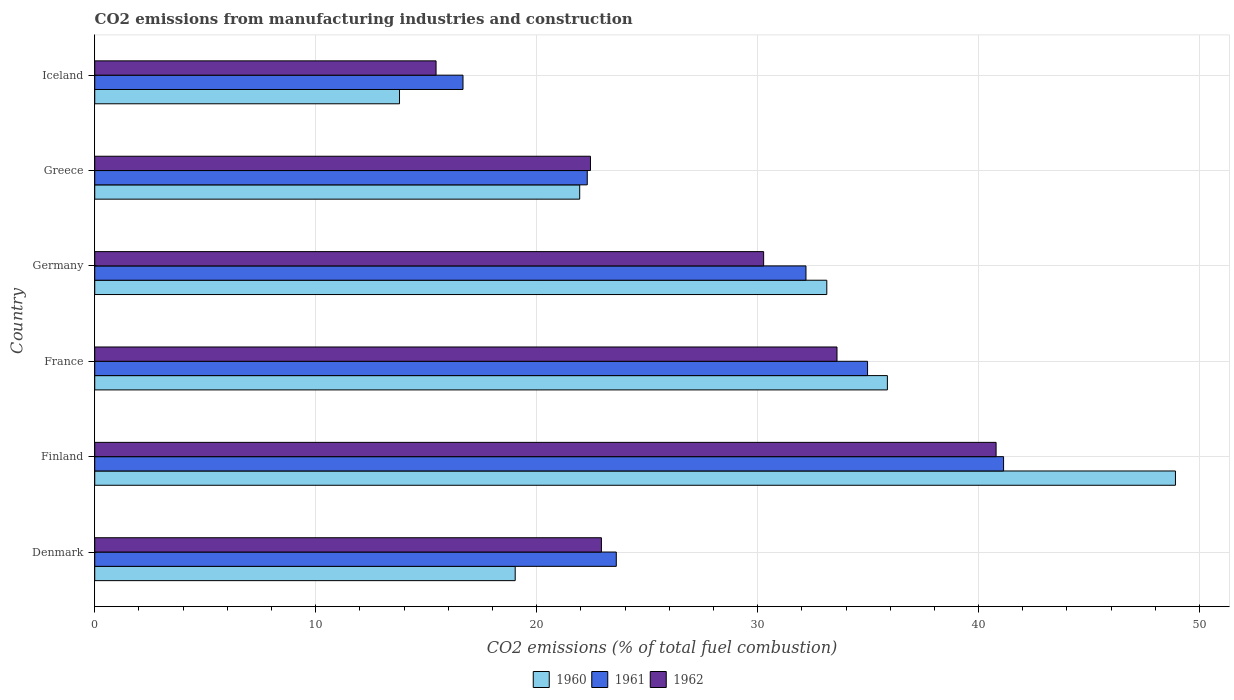How many bars are there on the 3rd tick from the bottom?
Give a very brief answer. 3. In how many cases, is the number of bars for a given country not equal to the number of legend labels?
Make the answer very short. 0. What is the amount of CO2 emitted in 1961 in Iceland?
Your answer should be very brief. 16.67. Across all countries, what is the maximum amount of CO2 emitted in 1962?
Provide a short and direct response. 40.79. Across all countries, what is the minimum amount of CO2 emitted in 1960?
Offer a very short reply. 13.79. In which country was the amount of CO2 emitted in 1960 maximum?
Provide a succinct answer. Finland. What is the total amount of CO2 emitted in 1961 in the graph?
Provide a succinct answer. 170.85. What is the difference between the amount of CO2 emitted in 1961 in Finland and that in Greece?
Offer a terse response. 18.84. What is the difference between the amount of CO2 emitted in 1962 in Iceland and the amount of CO2 emitted in 1960 in France?
Offer a terse response. -20.43. What is the average amount of CO2 emitted in 1960 per country?
Give a very brief answer. 28.78. What is the difference between the amount of CO2 emitted in 1961 and amount of CO2 emitted in 1960 in Denmark?
Offer a terse response. 4.57. In how many countries, is the amount of CO2 emitted in 1962 greater than 20 %?
Give a very brief answer. 5. What is the ratio of the amount of CO2 emitted in 1960 in France to that in Iceland?
Provide a succinct answer. 2.6. What is the difference between the highest and the second highest amount of CO2 emitted in 1960?
Your answer should be compact. 13.04. What is the difference between the highest and the lowest amount of CO2 emitted in 1962?
Provide a succinct answer. 25.34. What does the 1st bar from the top in Finland represents?
Keep it short and to the point. 1962. What does the 3rd bar from the bottom in Germany represents?
Your response must be concise. 1962. Is it the case that in every country, the sum of the amount of CO2 emitted in 1960 and amount of CO2 emitted in 1961 is greater than the amount of CO2 emitted in 1962?
Your answer should be compact. Yes. How many bars are there?
Your response must be concise. 18. Are all the bars in the graph horizontal?
Make the answer very short. Yes. Does the graph contain grids?
Your answer should be compact. Yes. How many legend labels are there?
Your answer should be very brief. 3. How are the legend labels stacked?
Make the answer very short. Horizontal. What is the title of the graph?
Offer a very short reply. CO2 emissions from manufacturing industries and construction. What is the label or title of the X-axis?
Provide a short and direct response. CO2 emissions (% of total fuel combustion). What is the CO2 emissions (% of total fuel combustion) of 1960 in Denmark?
Offer a very short reply. 19.03. What is the CO2 emissions (% of total fuel combustion) in 1961 in Denmark?
Provide a short and direct response. 23.6. What is the CO2 emissions (% of total fuel combustion) of 1962 in Denmark?
Your response must be concise. 22.93. What is the CO2 emissions (% of total fuel combustion) in 1960 in Finland?
Offer a very short reply. 48.91. What is the CO2 emissions (% of total fuel combustion) in 1961 in Finland?
Provide a succinct answer. 41.13. What is the CO2 emissions (% of total fuel combustion) in 1962 in Finland?
Your answer should be compact. 40.79. What is the CO2 emissions (% of total fuel combustion) in 1960 in France?
Give a very brief answer. 35.87. What is the CO2 emissions (% of total fuel combustion) of 1961 in France?
Your response must be concise. 34.98. What is the CO2 emissions (% of total fuel combustion) in 1962 in France?
Your answer should be very brief. 33.59. What is the CO2 emissions (% of total fuel combustion) in 1960 in Germany?
Your answer should be very brief. 33.13. What is the CO2 emissions (% of total fuel combustion) in 1961 in Germany?
Make the answer very short. 32.19. What is the CO2 emissions (% of total fuel combustion) in 1962 in Germany?
Offer a terse response. 30.27. What is the CO2 emissions (% of total fuel combustion) of 1960 in Greece?
Offer a terse response. 21.95. What is the CO2 emissions (% of total fuel combustion) in 1961 in Greece?
Your response must be concise. 22.29. What is the CO2 emissions (% of total fuel combustion) of 1962 in Greece?
Your response must be concise. 22.44. What is the CO2 emissions (% of total fuel combustion) in 1960 in Iceland?
Offer a very short reply. 13.79. What is the CO2 emissions (% of total fuel combustion) of 1961 in Iceland?
Offer a terse response. 16.67. What is the CO2 emissions (% of total fuel combustion) of 1962 in Iceland?
Offer a terse response. 15.45. Across all countries, what is the maximum CO2 emissions (% of total fuel combustion) of 1960?
Provide a succinct answer. 48.91. Across all countries, what is the maximum CO2 emissions (% of total fuel combustion) in 1961?
Provide a succinct answer. 41.13. Across all countries, what is the maximum CO2 emissions (% of total fuel combustion) in 1962?
Give a very brief answer. 40.79. Across all countries, what is the minimum CO2 emissions (% of total fuel combustion) in 1960?
Keep it short and to the point. 13.79. Across all countries, what is the minimum CO2 emissions (% of total fuel combustion) in 1961?
Make the answer very short. 16.67. Across all countries, what is the minimum CO2 emissions (% of total fuel combustion) in 1962?
Ensure brevity in your answer.  15.45. What is the total CO2 emissions (% of total fuel combustion) of 1960 in the graph?
Ensure brevity in your answer.  172.68. What is the total CO2 emissions (% of total fuel combustion) of 1961 in the graph?
Ensure brevity in your answer.  170.85. What is the total CO2 emissions (% of total fuel combustion) of 1962 in the graph?
Keep it short and to the point. 165.47. What is the difference between the CO2 emissions (% of total fuel combustion) of 1960 in Denmark and that in Finland?
Provide a succinct answer. -29.88. What is the difference between the CO2 emissions (% of total fuel combustion) in 1961 in Denmark and that in Finland?
Keep it short and to the point. -17.53. What is the difference between the CO2 emissions (% of total fuel combustion) of 1962 in Denmark and that in Finland?
Give a very brief answer. -17.86. What is the difference between the CO2 emissions (% of total fuel combustion) in 1960 in Denmark and that in France?
Provide a short and direct response. -16.84. What is the difference between the CO2 emissions (% of total fuel combustion) in 1961 in Denmark and that in France?
Ensure brevity in your answer.  -11.37. What is the difference between the CO2 emissions (% of total fuel combustion) in 1962 in Denmark and that in France?
Give a very brief answer. -10.66. What is the difference between the CO2 emissions (% of total fuel combustion) of 1960 in Denmark and that in Germany?
Ensure brevity in your answer.  -14.1. What is the difference between the CO2 emissions (% of total fuel combustion) of 1961 in Denmark and that in Germany?
Offer a very short reply. -8.58. What is the difference between the CO2 emissions (% of total fuel combustion) in 1962 in Denmark and that in Germany?
Make the answer very short. -7.34. What is the difference between the CO2 emissions (% of total fuel combustion) in 1960 in Denmark and that in Greece?
Keep it short and to the point. -2.92. What is the difference between the CO2 emissions (% of total fuel combustion) in 1961 in Denmark and that in Greece?
Your answer should be very brief. 1.31. What is the difference between the CO2 emissions (% of total fuel combustion) of 1962 in Denmark and that in Greece?
Give a very brief answer. 0.5. What is the difference between the CO2 emissions (% of total fuel combustion) of 1960 in Denmark and that in Iceland?
Offer a terse response. 5.24. What is the difference between the CO2 emissions (% of total fuel combustion) of 1961 in Denmark and that in Iceland?
Your answer should be compact. 6.94. What is the difference between the CO2 emissions (% of total fuel combustion) in 1962 in Denmark and that in Iceland?
Offer a terse response. 7.48. What is the difference between the CO2 emissions (% of total fuel combustion) in 1960 in Finland and that in France?
Your response must be concise. 13.04. What is the difference between the CO2 emissions (% of total fuel combustion) of 1961 in Finland and that in France?
Make the answer very short. 6.16. What is the difference between the CO2 emissions (% of total fuel combustion) of 1962 in Finland and that in France?
Your response must be concise. 7.2. What is the difference between the CO2 emissions (% of total fuel combustion) of 1960 in Finland and that in Germany?
Provide a succinct answer. 15.78. What is the difference between the CO2 emissions (% of total fuel combustion) in 1961 in Finland and that in Germany?
Offer a very short reply. 8.94. What is the difference between the CO2 emissions (% of total fuel combustion) in 1962 in Finland and that in Germany?
Provide a succinct answer. 10.52. What is the difference between the CO2 emissions (% of total fuel combustion) in 1960 in Finland and that in Greece?
Ensure brevity in your answer.  26.96. What is the difference between the CO2 emissions (% of total fuel combustion) of 1961 in Finland and that in Greece?
Your answer should be compact. 18.84. What is the difference between the CO2 emissions (% of total fuel combustion) of 1962 in Finland and that in Greece?
Offer a very short reply. 18.36. What is the difference between the CO2 emissions (% of total fuel combustion) in 1960 in Finland and that in Iceland?
Offer a very short reply. 35.12. What is the difference between the CO2 emissions (% of total fuel combustion) of 1961 in Finland and that in Iceland?
Provide a succinct answer. 24.46. What is the difference between the CO2 emissions (% of total fuel combustion) in 1962 in Finland and that in Iceland?
Your answer should be compact. 25.34. What is the difference between the CO2 emissions (% of total fuel combustion) of 1960 in France and that in Germany?
Your answer should be compact. 2.74. What is the difference between the CO2 emissions (% of total fuel combustion) in 1961 in France and that in Germany?
Your answer should be very brief. 2.79. What is the difference between the CO2 emissions (% of total fuel combustion) in 1962 in France and that in Germany?
Ensure brevity in your answer.  3.32. What is the difference between the CO2 emissions (% of total fuel combustion) of 1960 in France and that in Greece?
Your answer should be compact. 13.92. What is the difference between the CO2 emissions (% of total fuel combustion) in 1961 in France and that in Greece?
Your answer should be compact. 12.69. What is the difference between the CO2 emissions (% of total fuel combustion) of 1962 in France and that in Greece?
Provide a succinct answer. 11.16. What is the difference between the CO2 emissions (% of total fuel combustion) of 1960 in France and that in Iceland?
Your answer should be very brief. 22.08. What is the difference between the CO2 emissions (% of total fuel combustion) of 1961 in France and that in Iceland?
Your response must be concise. 18.31. What is the difference between the CO2 emissions (% of total fuel combustion) of 1962 in France and that in Iceland?
Provide a succinct answer. 18.14. What is the difference between the CO2 emissions (% of total fuel combustion) of 1960 in Germany and that in Greece?
Provide a succinct answer. 11.18. What is the difference between the CO2 emissions (% of total fuel combustion) in 1961 in Germany and that in Greece?
Give a very brief answer. 9.9. What is the difference between the CO2 emissions (% of total fuel combustion) in 1962 in Germany and that in Greece?
Offer a terse response. 7.84. What is the difference between the CO2 emissions (% of total fuel combustion) of 1960 in Germany and that in Iceland?
Keep it short and to the point. 19.34. What is the difference between the CO2 emissions (% of total fuel combustion) in 1961 in Germany and that in Iceland?
Keep it short and to the point. 15.52. What is the difference between the CO2 emissions (% of total fuel combustion) of 1962 in Germany and that in Iceland?
Offer a very short reply. 14.82. What is the difference between the CO2 emissions (% of total fuel combustion) in 1960 in Greece and that in Iceland?
Offer a terse response. 8.15. What is the difference between the CO2 emissions (% of total fuel combustion) of 1961 in Greece and that in Iceland?
Provide a short and direct response. 5.62. What is the difference between the CO2 emissions (% of total fuel combustion) of 1962 in Greece and that in Iceland?
Your response must be concise. 6.99. What is the difference between the CO2 emissions (% of total fuel combustion) of 1960 in Denmark and the CO2 emissions (% of total fuel combustion) of 1961 in Finland?
Make the answer very short. -22.1. What is the difference between the CO2 emissions (% of total fuel combustion) in 1960 in Denmark and the CO2 emissions (% of total fuel combustion) in 1962 in Finland?
Your answer should be compact. -21.76. What is the difference between the CO2 emissions (% of total fuel combustion) of 1961 in Denmark and the CO2 emissions (% of total fuel combustion) of 1962 in Finland?
Provide a short and direct response. -17.19. What is the difference between the CO2 emissions (% of total fuel combustion) in 1960 in Denmark and the CO2 emissions (% of total fuel combustion) in 1961 in France?
Provide a succinct answer. -15.95. What is the difference between the CO2 emissions (% of total fuel combustion) of 1960 in Denmark and the CO2 emissions (% of total fuel combustion) of 1962 in France?
Provide a short and direct response. -14.56. What is the difference between the CO2 emissions (% of total fuel combustion) in 1961 in Denmark and the CO2 emissions (% of total fuel combustion) in 1962 in France?
Keep it short and to the point. -9.99. What is the difference between the CO2 emissions (% of total fuel combustion) in 1960 in Denmark and the CO2 emissions (% of total fuel combustion) in 1961 in Germany?
Make the answer very short. -13.16. What is the difference between the CO2 emissions (% of total fuel combustion) of 1960 in Denmark and the CO2 emissions (% of total fuel combustion) of 1962 in Germany?
Offer a terse response. -11.24. What is the difference between the CO2 emissions (% of total fuel combustion) in 1961 in Denmark and the CO2 emissions (% of total fuel combustion) in 1962 in Germany?
Ensure brevity in your answer.  -6.67. What is the difference between the CO2 emissions (% of total fuel combustion) of 1960 in Denmark and the CO2 emissions (% of total fuel combustion) of 1961 in Greece?
Make the answer very short. -3.26. What is the difference between the CO2 emissions (% of total fuel combustion) in 1960 in Denmark and the CO2 emissions (% of total fuel combustion) in 1962 in Greece?
Give a very brief answer. -3.41. What is the difference between the CO2 emissions (% of total fuel combustion) of 1961 in Denmark and the CO2 emissions (% of total fuel combustion) of 1962 in Greece?
Provide a short and direct response. 1.17. What is the difference between the CO2 emissions (% of total fuel combustion) of 1960 in Denmark and the CO2 emissions (% of total fuel combustion) of 1961 in Iceland?
Offer a very short reply. 2.36. What is the difference between the CO2 emissions (% of total fuel combustion) of 1960 in Denmark and the CO2 emissions (% of total fuel combustion) of 1962 in Iceland?
Offer a terse response. 3.58. What is the difference between the CO2 emissions (% of total fuel combustion) in 1961 in Denmark and the CO2 emissions (% of total fuel combustion) in 1962 in Iceland?
Your response must be concise. 8.16. What is the difference between the CO2 emissions (% of total fuel combustion) of 1960 in Finland and the CO2 emissions (% of total fuel combustion) of 1961 in France?
Offer a terse response. 13.93. What is the difference between the CO2 emissions (% of total fuel combustion) in 1960 in Finland and the CO2 emissions (% of total fuel combustion) in 1962 in France?
Keep it short and to the point. 15.32. What is the difference between the CO2 emissions (% of total fuel combustion) in 1961 in Finland and the CO2 emissions (% of total fuel combustion) in 1962 in France?
Ensure brevity in your answer.  7.54. What is the difference between the CO2 emissions (% of total fuel combustion) of 1960 in Finland and the CO2 emissions (% of total fuel combustion) of 1961 in Germany?
Make the answer very short. 16.72. What is the difference between the CO2 emissions (% of total fuel combustion) in 1960 in Finland and the CO2 emissions (% of total fuel combustion) in 1962 in Germany?
Give a very brief answer. 18.64. What is the difference between the CO2 emissions (% of total fuel combustion) in 1961 in Finland and the CO2 emissions (% of total fuel combustion) in 1962 in Germany?
Provide a short and direct response. 10.86. What is the difference between the CO2 emissions (% of total fuel combustion) in 1960 in Finland and the CO2 emissions (% of total fuel combustion) in 1961 in Greece?
Offer a terse response. 26.62. What is the difference between the CO2 emissions (% of total fuel combustion) of 1960 in Finland and the CO2 emissions (% of total fuel combustion) of 1962 in Greece?
Give a very brief answer. 26.47. What is the difference between the CO2 emissions (% of total fuel combustion) of 1961 in Finland and the CO2 emissions (% of total fuel combustion) of 1962 in Greece?
Your response must be concise. 18.7. What is the difference between the CO2 emissions (% of total fuel combustion) in 1960 in Finland and the CO2 emissions (% of total fuel combustion) in 1961 in Iceland?
Your response must be concise. 32.24. What is the difference between the CO2 emissions (% of total fuel combustion) of 1960 in Finland and the CO2 emissions (% of total fuel combustion) of 1962 in Iceland?
Keep it short and to the point. 33.46. What is the difference between the CO2 emissions (% of total fuel combustion) in 1961 in Finland and the CO2 emissions (% of total fuel combustion) in 1962 in Iceland?
Offer a very short reply. 25.68. What is the difference between the CO2 emissions (% of total fuel combustion) in 1960 in France and the CO2 emissions (% of total fuel combustion) in 1961 in Germany?
Make the answer very short. 3.68. What is the difference between the CO2 emissions (% of total fuel combustion) in 1960 in France and the CO2 emissions (% of total fuel combustion) in 1962 in Germany?
Keep it short and to the point. 5.6. What is the difference between the CO2 emissions (% of total fuel combustion) in 1961 in France and the CO2 emissions (% of total fuel combustion) in 1962 in Germany?
Make the answer very short. 4.7. What is the difference between the CO2 emissions (% of total fuel combustion) of 1960 in France and the CO2 emissions (% of total fuel combustion) of 1961 in Greece?
Your response must be concise. 13.58. What is the difference between the CO2 emissions (% of total fuel combustion) of 1960 in France and the CO2 emissions (% of total fuel combustion) of 1962 in Greece?
Make the answer very short. 13.44. What is the difference between the CO2 emissions (% of total fuel combustion) of 1961 in France and the CO2 emissions (% of total fuel combustion) of 1962 in Greece?
Offer a very short reply. 12.54. What is the difference between the CO2 emissions (% of total fuel combustion) of 1960 in France and the CO2 emissions (% of total fuel combustion) of 1961 in Iceland?
Make the answer very short. 19.21. What is the difference between the CO2 emissions (% of total fuel combustion) in 1960 in France and the CO2 emissions (% of total fuel combustion) in 1962 in Iceland?
Your answer should be compact. 20.43. What is the difference between the CO2 emissions (% of total fuel combustion) in 1961 in France and the CO2 emissions (% of total fuel combustion) in 1962 in Iceland?
Provide a short and direct response. 19.53. What is the difference between the CO2 emissions (% of total fuel combustion) of 1960 in Germany and the CO2 emissions (% of total fuel combustion) of 1961 in Greece?
Your response must be concise. 10.84. What is the difference between the CO2 emissions (% of total fuel combustion) in 1960 in Germany and the CO2 emissions (% of total fuel combustion) in 1962 in Greece?
Your answer should be compact. 10.69. What is the difference between the CO2 emissions (% of total fuel combustion) of 1961 in Germany and the CO2 emissions (% of total fuel combustion) of 1962 in Greece?
Your answer should be compact. 9.75. What is the difference between the CO2 emissions (% of total fuel combustion) in 1960 in Germany and the CO2 emissions (% of total fuel combustion) in 1961 in Iceland?
Offer a terse response. 16.46. What is the difference between the CO2 emissions (% of total fuel combustion) of 1960 in Germany and the CO2 emissions (% of total fuel combustion) of 1962 in Iceland?
Provide a succinct answer. 17.68. What is the difference between the CO2 emissions (% of total fuel combustion) of 1961 in Germany and the CO2 emissions (% of total fuel combustion) of 1962 in Iceland?
Provide a short and direct response. 16.74. What is the difference between the CO2 emissions (% of total fuel combustion) of 1960 in Greece and the CO2 emissions (% of total fuel combustion) of 1961 in Iceland?
Offer a very short reply. 5.28. What is the difference between the CO2 emissions (% of total fuel combustion) of 1960 in Greece and the CO2 emissions (% of total fuel combustion) of 1962 in Iceland?
Your response must be concise. 6.5. What is the difference between the CO2 emissions (% of total fuel combustion) of 1961 in Greece and the CO2 emissions (% of total fuel combustion) of 1962 in Iceland?
Your answer should be very brief. 6.84. What is the average CO2 emissions (% of total fuel combustion) of 1960 per country?
Give a very brief answer. 28.78. What is the average CO2 emissions (% of total fuel combustion) of 1961 per country?
Ensure brevity in your answer.  28.48. What is the average CO2 emissions (% of total fuel combustion) in 1962 per country?
Ensure brevity in your answer.  27.58. What is the difference between the CO2 emissions (% of total fuel combustion) in 1960 and CO2 emissions (% of total fuel combustion) in 1961 in Denmark?
Ensure brevity in your answer.  -4.57. What is the difference between the CO2 emissions (% of total fuel combustion) in 1960 and CO2 emissions (% of total fuel combustion) in 1962 in Denmark?
Ensure brevity in your answer.  -3.9. What is the difference between the CO2 emissions (% of total fuel combustion) of 1961 and CO2 emissions (% of total fuel combustion) of 1962 in Denmark?
Provide a succinct answer. 0.67. What is the difference between the CO2 emissions (% of total fuel combustion) of 1960 and CO2 emissions (% of total fuel combustion) of 1961 in Finland?
Offer a very short reply. 7.78. What is the difference between the CO2 emissions (% of total fuel combustion) of 1960 and CO2 emissions (% of total fuel combustion) of 1962 in Finland?
Offer a terse response. 8.12. What is the difference between the CO2 emissions (% of total fuel combustion) of 1961 and CO2 emissions (% of total fuel combustion) of 1962 in Finland?
Provide a short and direct response. 0.34. What is the difference between the CO2 emissions (% of total fuel combustion) of 1960 and CO2 emissions (% of total fuel combustion) of 1961 in France?
Provide a succinct answer. 0.9. What is the difference between the CO2 emissions (% of total fuel combustion) of 1960 and CO2 emissions (% of total fuel combustion) of 1962 in France?
Offer a terse response. 2.28. What is the difference between the CO2 emissions (% of total fuel combustion) in 1961 and CO2 emissions (% of total fuel combustion) in 1962 in France?
Offer a very short reply. 1.38. What is the difference between the CO2 emissions (% of total fuel combustion) in 1960 and CO2 emissions (% of total fuel combustion) in 1961 in Germany?
Your answer should be compact. 0.94. What is the difference between the CO2 emissions (% of total fuel combustion) of 1960 and CO2 emissions (% of total fuel combustion) of 1962 in Germany?
Offer a very short reply. 2.86. What is the difference between the CO2 emissions (% of total fuel combustion) in 1961 and CO2 emissions (% of total fuel combustion) in 1962 in Germany?
Ensure brevity in your answer.  1.92. What is the difference between the CO2 emissions (% of total fuel combustion) of 1960 and CO2 emissions (% of total fuel combustion) of 1961 in Greece?
Offer a very short reply. -0.34. What is the difference between the CO2 emissions (% of total fuel combustion) of 1960 and CO2 emissions (% of total fuel combustion) of 1962 in Greece?
Your answer should be very brief. -0.49. What is the difference between the CO2 emissions (% of total fuel combustion) in 1961 and CO2 emissions (% of total fuel combustion) in 1962 in Greece?
Provide a short and direct response. -0.15. What is the difference between the CO2 emissions (% of total fuel combustion) in 1960 and CO2 emissions (% of total fuel combustion) in 1961 in Iceland?
Your response must be concise. -2.87. What is the difference between the CO2 emissions (% of total fuel combustion) of 1960 and CO2 emissions (% of total fuel combustion) of 1962 in Iceland?
Make the answer very short. -1.65. What is the difference between the CO2 emissions (% of total fuel combustion) in 1961 and CO2 emissions (% of total fuel combustion) in 1962 in Iceland?
Your response must be concise. 1.22. What is the ratio of the CO2 emissions (% of total fuel combustion) in 1960 in Denmark to that in Finland?
Give a very brief answer. 0.39. What is the ratio of the CO2 emissions (% of total fuel combustion) of 1961 in Denmark to that in Finland?
Give a very brief answer. 0.57. What is the ratio of the CO2 emissions (% of total fuel combustion) of 1962 in Denmark to that in Finland?
Keep it short and to the point. 0.56. What is the ratio of the CO2 emissions (% of total fuel combustion) in 1960 in Denmark to that in France?
Give a very brief answer. 0.53. What is the ratio of the CO2 emissions (% of total fuel combustion) of 1961 in Denmark to that in France?
Make the answer very short. 0.67. What is the ratio of the CO2 emissions (% of total fuel combustion) in 1962 in Denmark to that in France?
Offer a very short reply. 0.68. What is the ratio of the CO2 emissions (% of total fuel combustion) in 1960 in Denmark to that in Germany?
Ensure brevity in your answer.  0.57. What is the ratio of the CO2 emissions (% of total fuel combustion) in 1961 in Denmark to that in Germany?
Your answer should be very brief. 0.73. What is the ratio of the CO2 emissions (% of total fuel combustion) of 1962 in Denmark to that in Germany?
Provide a succinct answer. 0.76. What is the ratio of the CO2 emissions (% of total fuel combustion) of 1960 in Denmark to that in Greece?
Your response must be concise. 0.87. What is the ratio of the CO2 emissions (% of total fuel combustion) in 1961 in Denmark to that in Greece?
Give a very brief answer. 1.06. What is the ratio of the CO2 emissions (% of total fuel combustion) in 1962 in Denmark to that in Greece?
Your response must be concise. 1.02. What is the ratio of the CO2 emissions (% of total fuel combustion) of 1960 in Denmark to that in Iceland?
Offer a terse response. 1.38. What is the ratio of the CO2 emissions (% of total fuel combustion) in 1961 in Denmark to that in Iceland?
Keep it short and to the point. 1.42. What is the ratio of the CO2 emissions (% of total fuel combustion) in 1962 in Denmark to that in Iceland?
Provide a short and direct response. 1.48. What is the ratio of the CO2 emissions (% of total fuel combustion) of 1960 in Finland to that in France?
Offer a very short reply. 1.36. What is the ratio of the CO2 emissions (% of total fuel combustion) of 1961 in Finland to that in France?
Give a very brief answer. 1.18. What is the ratio of the CO2 emissions (% of total fuel combustion) of 1962 in Finland to that in France?
Make the answer very short. 1.21. What is the ratio of the CO2 emissions (% of total fuel combustion) in 1960 in Finland to that in Germany?
Keep it short and to the point. 1.48. What is the ratio of the CO2 emissions (% of total fuel combustion) of 1961 in Finland to that in Germany?
Provide a short and direct response. 1.28. What is the ratio of the CO2 emissions (% of total fuel combustion) in 1962 in Finland to that in Germany?
Offer a terse response. 1.35. What is the ratio of the CO2 emissions (% of total fuel combustion) of 1960 in Finland to that in Greece?
Keep it short and to the point. 2.23. What is the ratio of the CO2 emissions (% of total fuel combustion) of 1961 in Finland to that in Greece?
Ensure brevity in your answer.  1.85. What is the ratio of the CO2 emissions (% of total fuel combustion) in 1962 in Finland to that in Greece?
Keep it short and to the point. 1.82. What is the ratio of the CO2 emissions (% of total fuel combustion) of 1960 in Finland to that in Iceland?
Offer a very short reply. 3.55. What is the ratio of the CO2 emissions (% of total fuel combustion) in 1961 in Finland to that in Iceland?
Your answer should be very brief. 2.47. What is the ratio of the CO2 emissions (% of total fuel combustion) of 1962 in Finland to that in Iceland?
Provide a succinct answer. 2.64. What is the ratio of the CO2 emissions (% of total fuel combustion) of 1960 in France to that in Germany?
Ensure brevity in your answer.  1.08. What is the ratio of the CO2 emissions (% of total fuel combustion) in 1961 in France to that in Germany?
Provide a succinct answer. 1.09. What is the ratio of the CO2 emissions (% of total fuel combustion) of 1962 in France to that in Germany?
Make the answer very short. 1.11. What is the ratio of the CO2 emissions (% of total fuel combustion) of 1960 in France to that in Greece?
Make the answer very short. 1.63. What is the ratio of the CO2 emissions (% of total fuel combustion) in 1961 in France to that in Greece?
Provide a succinct answer. 1.57. What is the ratio of the CO2 emissions (% of total fuel combustion) of 1962 in France to that in Greece?
Keep it short and to the point. 1.5. What is the ratio of the CO2 emissions (% of total fuel combustion) in 1960 in France to that in Iceland?
Your response must be concise. 2.6. What is the ratio of the CO2 emissions (% of total fuel combustion) of 1961 in France to that in Iceland?
Ensure brevity in your answer.  2.1. What is the ratio of the CO2 emissions (% of total fuel combustion) of 1962 in France to that in Iceland?
Give a very brief answer. 2.17. What is the ratio of the CO2 emissions (% of total fuel combustion) of 1960 in Germany to that in Greece?
Provide a succinct answer. 1.51. What is the ratio of the CO2 emissions (% of total fuel combustion) of 1961 in Germany to that in Greece?
Provide a short and direct response. 1.44. What is the ratio of the CO2 emissions (% of total fuel combustion) of 1962 in Germany to that in Greece?
Ensure brevity in your answer.  1.35. What is the ratio of the CO2 emissions (% of total fuel combustion) in 1960 in Germany to that in Iceland?
Make the answer very short. 2.4. What is the ratio of the CO2 emissions (% of total fuel combustion) of 1961 in Germany to that in Iceland?
Provide a succinct answer. 1.93. What is the ratio of the CO2 emissions (% of total fuel combustion) in 1962 in Germany to that in Iceland?
Offer a very short reply. 1.96. What is the ratio of the CO2 emissions (% of total fuel combustion) in 1960 in Greece to that in Iceland?
Provide a short and direct response. 1.59. What is the ratio of the CO2 emissions (% of total fuel combustion) of 1961 in Greece to that in Iceland?
Offer a terse response. 1.34. What is the ratio of the CO2 emissions (% of total fuel combustion) of 1962 in Greece to that in Iceland?
Your response must be concise. 1.45. What is the difference between the highest and the second highest CO2 emissions (% of total fuel combustion) in 1960?
Make the answer very short. 13.04. What is the difference between the highest and the second highest CO2 emissions (% of total fuel combustion) in 1961?
Your answer should be compact. 6.16. What is the difference between the highest and the second highest CO2 emissions (% of total fuel combustion) in 1962?
Your answer should be very brief. 7.2. What is the difference between the highest and the lowest CO2 emissions (% of total fuel combustion) in 1960?
Your answer should be very brief. 35.12. What is the difference between the highest and the lowest CO2 emissions (% of total fuel combustion) in 1961?
Offer a very short reply. 24.46. What is the difference between the highest and the lowest CO2 emissions (% of total fuel combustion) of 1962?
Give a very brief answer. 25.34. 